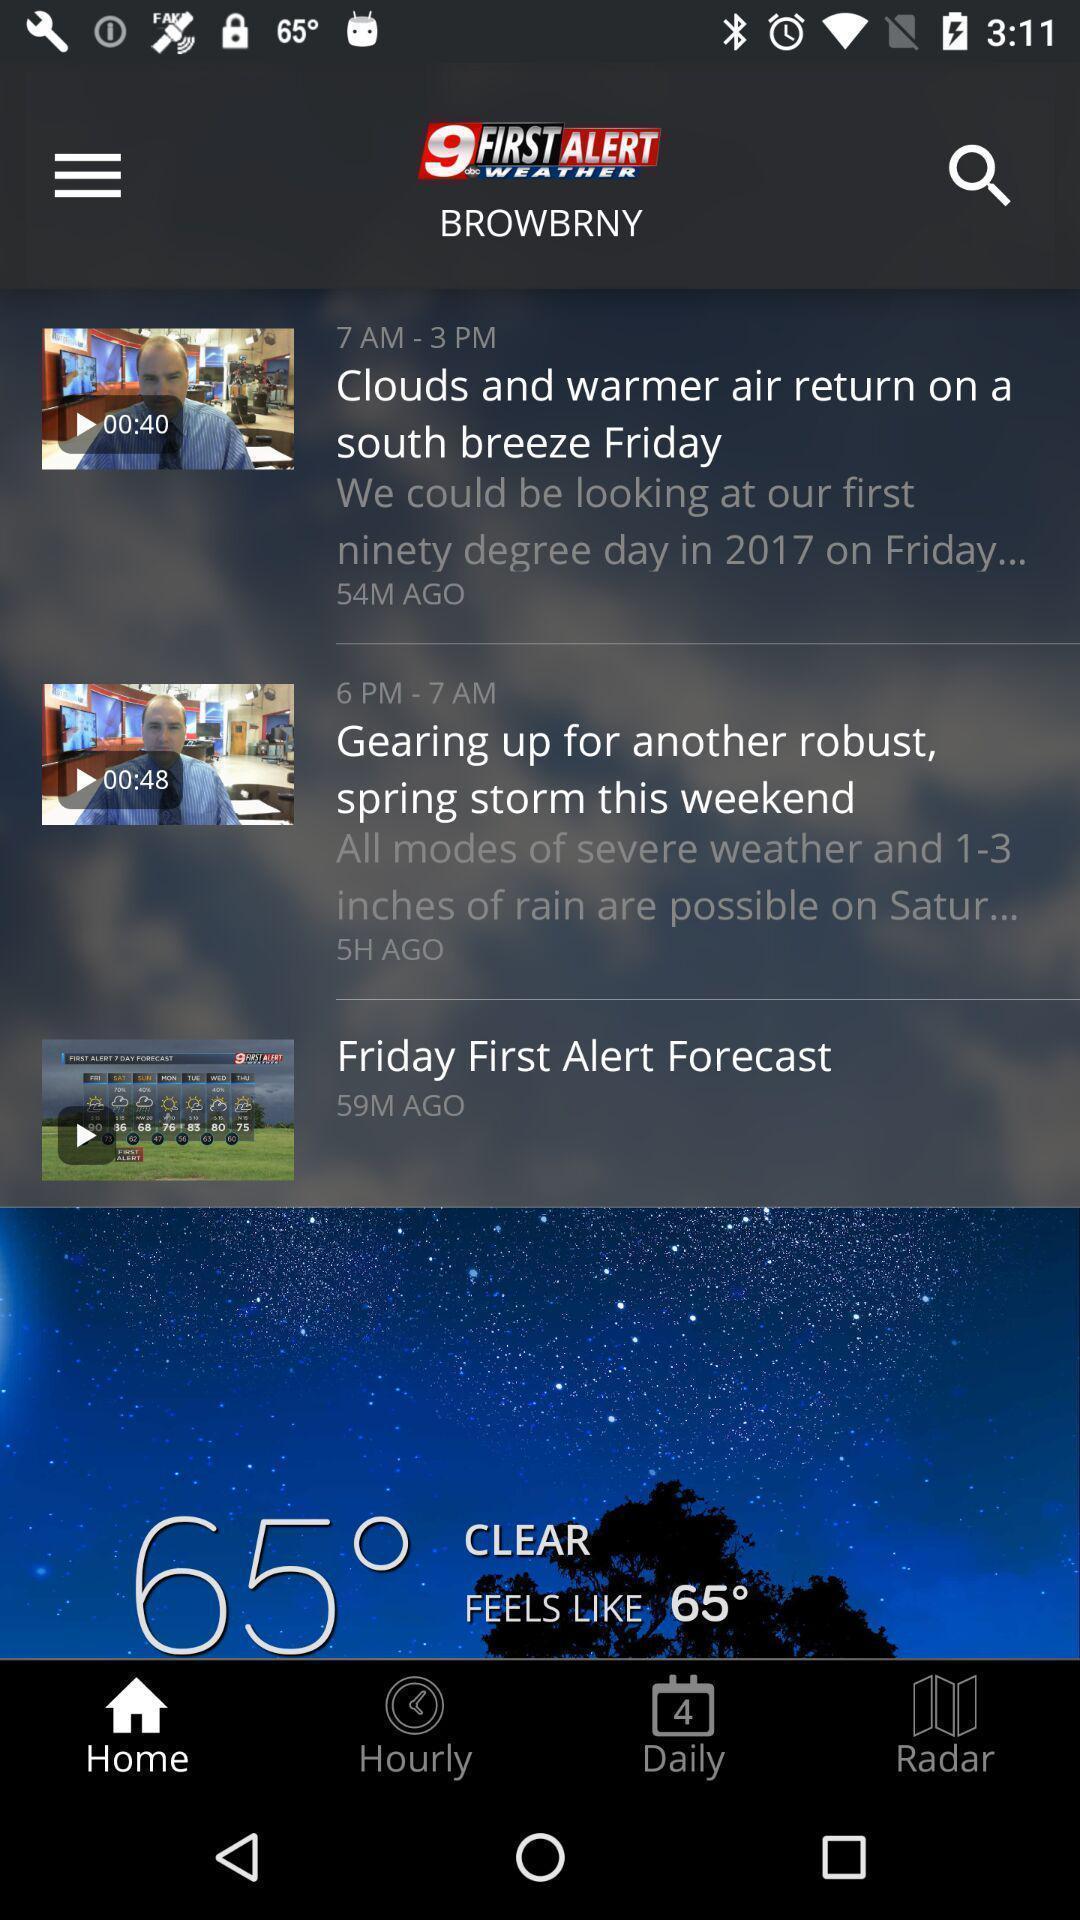What can you discern from this picture? Screen page of a weather app. 